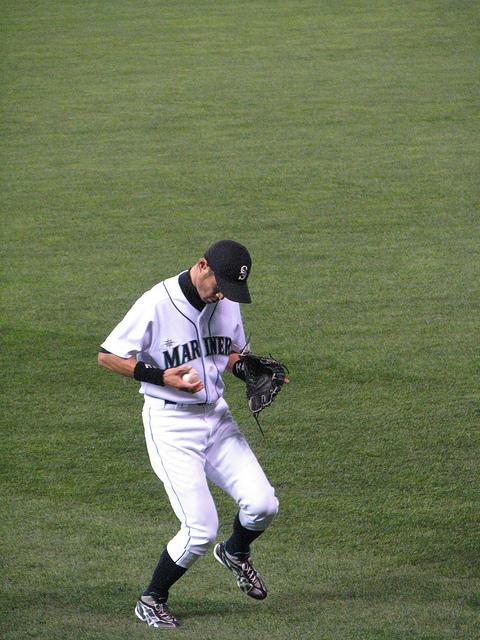Is this a pitch?
Answer briefly. No. Did he make the catch successfully?
Write a very short answer. Yes. What letter is on his hat?
Give a very brief answer. S. What did the player land on?
Be succinct. Grass. What color is the hat?
Be succinct. Black. Is this man holding the baseball in his hand in the picture?
Quick response, please. Yes. Is this a professional team?
Give a very brief answer. Yes. What color are his socks?
Answer briefly. Black. What is the man looking at?
Write a very short answer. Ball. What team does the man play for?
Answer briefly. Mariners. Where is the ball?
Give a very brief answer. In hand. What does it say on the boys shirt?
Concise answer only. Mariners. What color are the uniforms?
Give a very brief answer. White. 